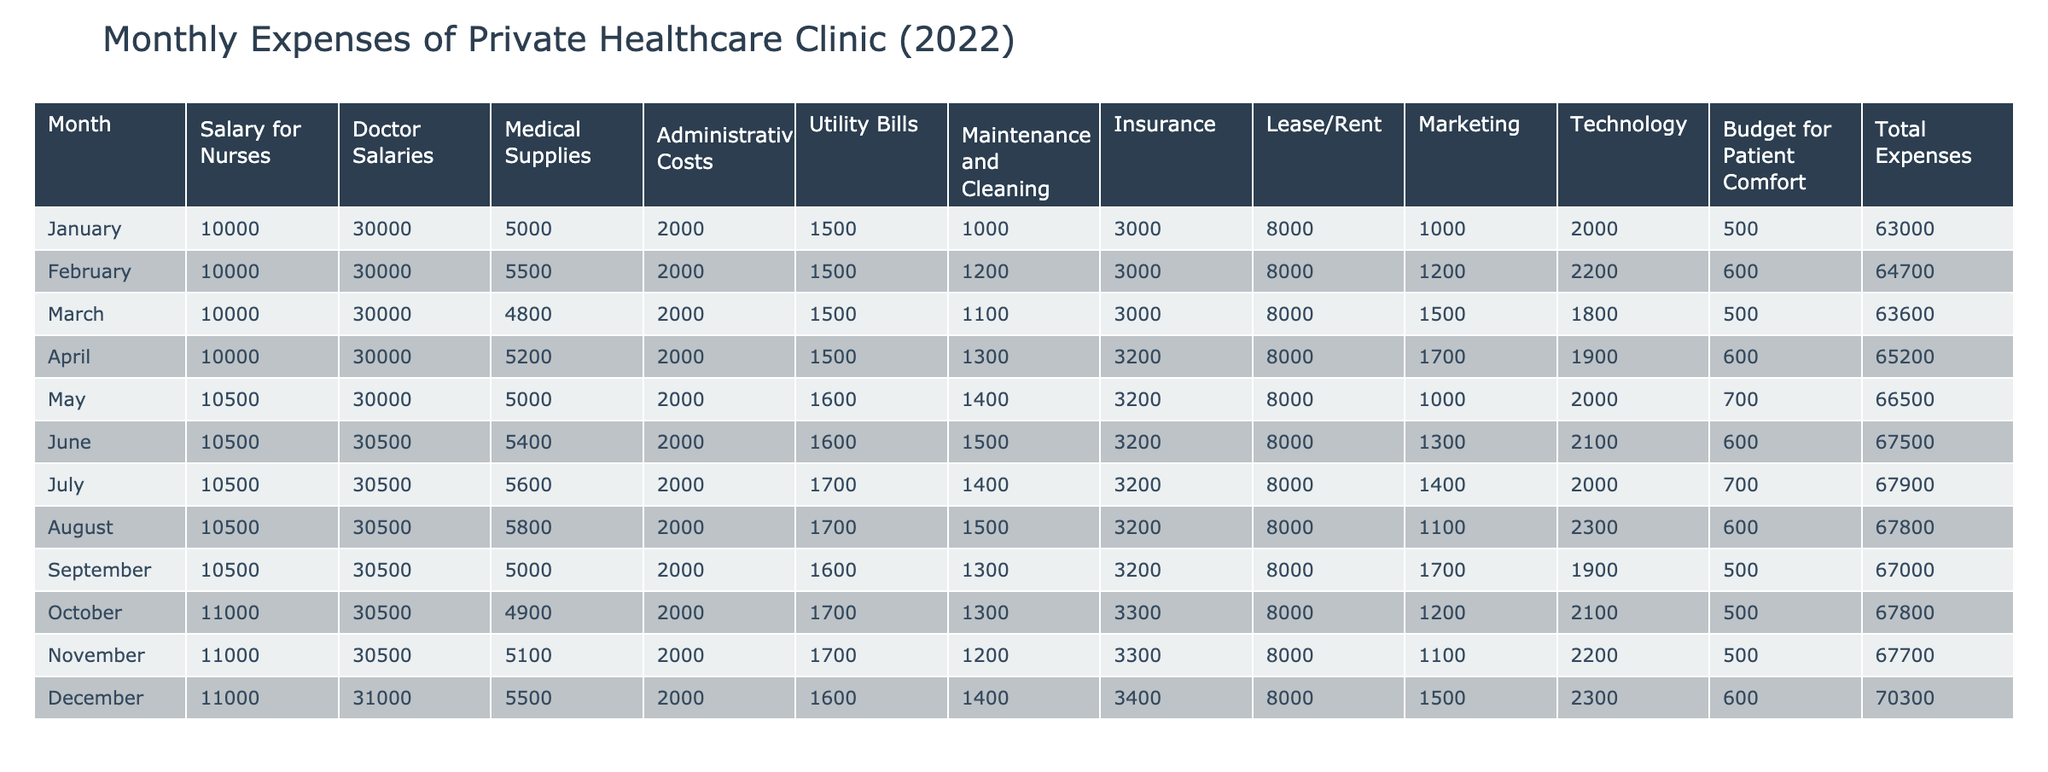What is the total expense for the month of June? The table shows the total expenses for each month, and for June, the total expenses are listed as 67500.
Answer: 67500 What month had the highest utilities expense? By looking at the utility bills for each month, the month with the highest expenses is July, which had utility bills amounting to 1700.
Answer: July What is the average salary for doctors throughout the year? To find the average salary for doctors, add the doctor salaries for each month over 12 months: (30000*3 + 30500*6 + 31000*3) = 364000, then divide by 12, which gives an average of 30333.33, rounded to 30333.
Answer: 30333 Did the total expenses exceed 67000 more than once? Checking the total expenses for each month, it exceeds 67000 in January, February, April, May, June, July, August, October, November, and December - indicating that it exceeds 67000 in 10 months.
Answer: Yes What was the month with the least medical supplies expense? The lowest medical supplies expense is noted for March, which was 4800.
Answer: March How much did the clinic spend on insurance throughout the year? The insurance expenses are: (3000 + 3000 + 3000 + 3200 + 3200 + 3200 + 3200 + 3200 + 3300 + 3300 + 3400) = 37500 throughout the year.
Answer: 37500 What is the difference in total expenses between December and January? When comparing December's total expenses of 70300 and January's total expenses of 63000, the difference is calculated as 70300 - 63000 = 7000.
Answer: 7000 Which month had the highest marketing expenses? The marketing expenses are highest in April with a value of 1700.
Answer: April How consistent were the nurse salaries throughout the year? The nurse salaries were 10000 for the first three months, then 10500 for the next six, and finally 11000 for the last three months, showing a consistent increase across the year without fluctuations.
Answer: Consistent 